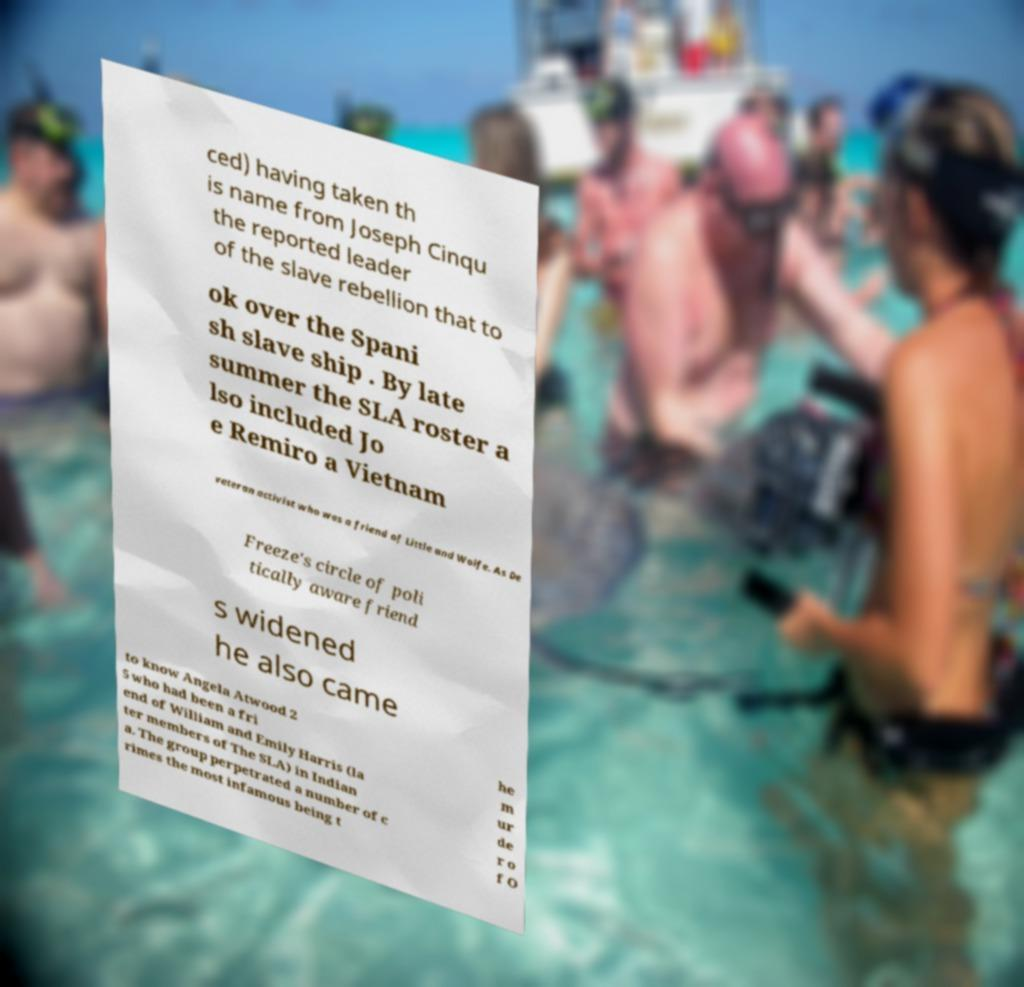Can you accurately transcribe the text from the provided image for me? ced) having taken th is name from Joseph Cinqu the reported leader of the slave rebellion that to ok over the Spani sh slave ship . By late summer the SLA roster a lso included Jo e Remiro a Vietnam veteran activist who was a friend of Little and Wolfe. As De Freeze's circle of poli tically aware friend s widened he also came to know Angela Atwood 2 5 who had been a fri end of William and Emily Harris (la ter members of The SLA) in Indian a. The group perpetrated a number of c rimes the most infamous being t he m ur de r o f O 